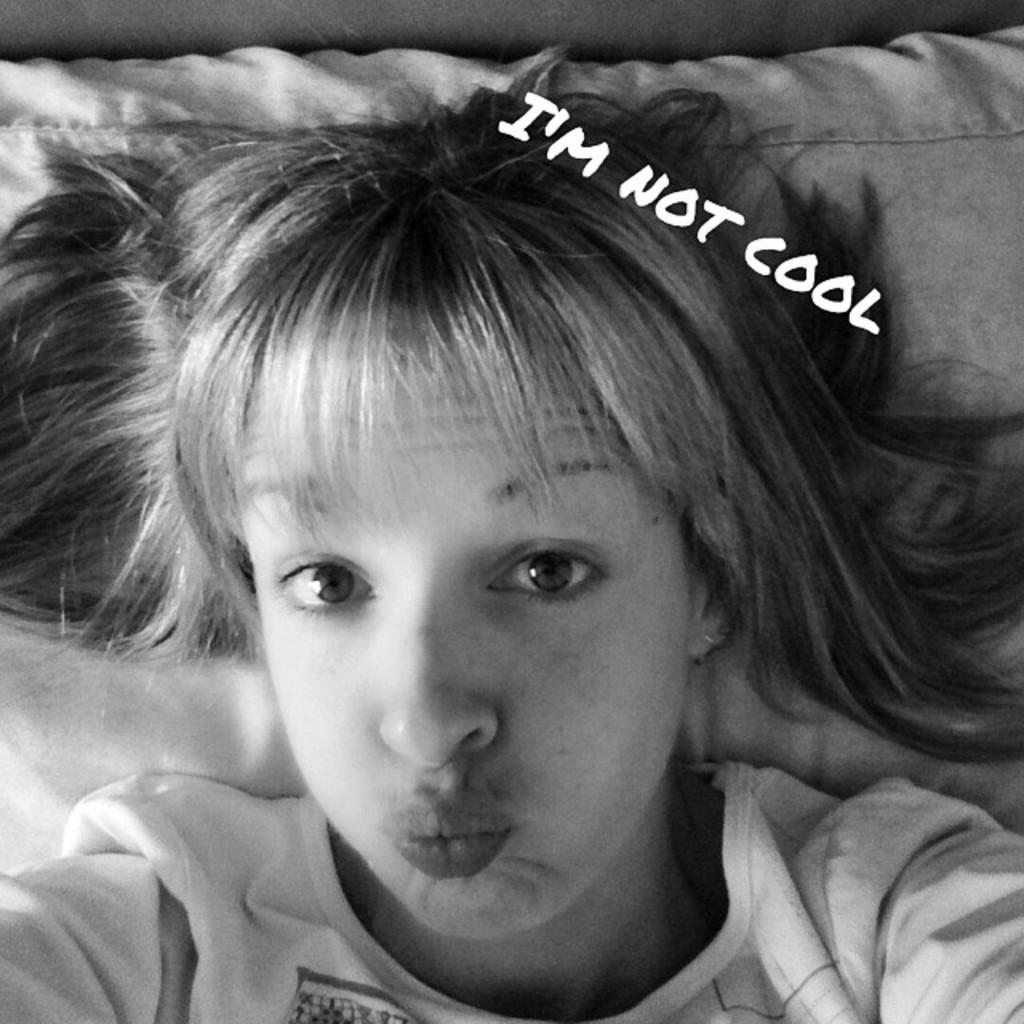What is the color scheme of the image? The image is black and white. What is the woman in the image doing? The woman is laying on a bed and giving a pose for the picture. What is the purpose of the edited text at the top of the image? The edited text at the top of the image is likely used for a title, caption, or other descriptive information. Can you tell me what time the clock shows in the image? There is no clock present in the image, so it is not possible to determine the time. What type of pipe is the woman holding in the image? There is no pipe present in the image; the woman is laying on a bed and posing for the picture. 